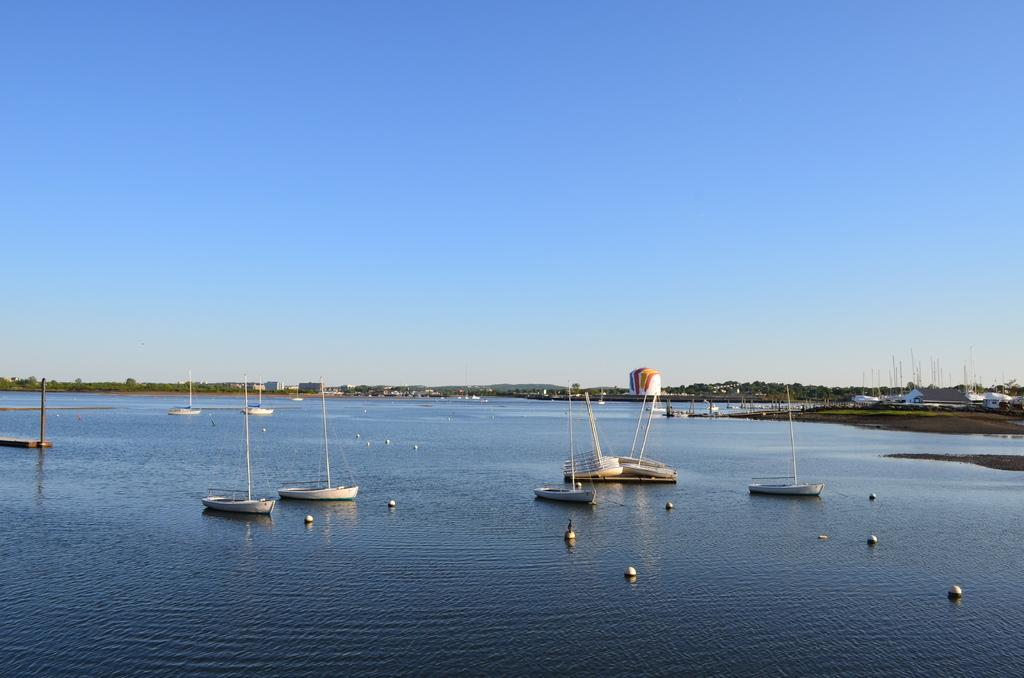What is on the water in the image? There are boats on the water in the image. What can be seen in the background of the image? There are trees and buildings in the background of the image. What is the color of the trees in the image? The trees are green in the image. What is the color of the sky in the image? The sky is blue and white in the image. How many potatoes can be seen floating in the water in the image? There are no potatoes visible in the image; it features boats on the water. What historical discovery is being made in the image? There is no indication of a historical discovery being made in the image. 